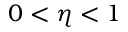Convert formula to latex. <formula><loc_0><loc_0><loc_500><loc_500>0 < \eta < 1</formula> 